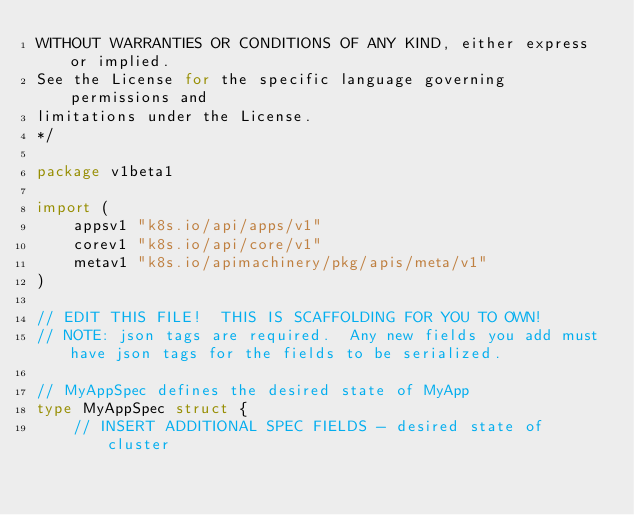<code> <loc_0><loc_0><loc_500><loc_500><_Go_>WITHOUT WARRANTIES OR CONDITIONS OF ANY KIND, either express or implied.
See the License for the specific language governing permissions and
limitations under the License.
*/

package v1beta1

import (
	appsv1 "k8s.io/api/apps/v1"
	corev1 "k8s.io/api/core/v1"
	metav1 "k8s.io/apimachinery/pkg/apis/meta/v1"
)

// EDIT THIS FILE!  THIS IS SCAFFOLDING FOR YOU TO OWN!
// NOTE: json tags are required.  Any new fields you add must have json tags for the fields to be serialized.

// MyAppSpec defines the desired state of MyApp
type MyAppSpec struct {
	// INSERT ADDITIONAL SPEC FIELDS - desired state of cluster</code> 